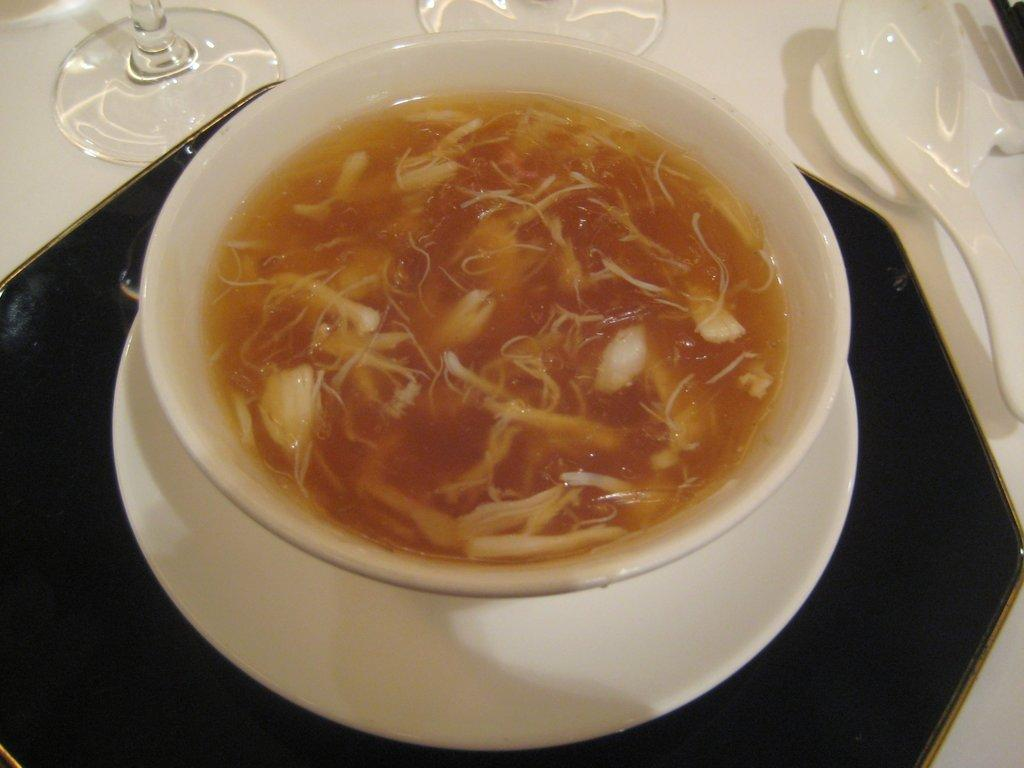What is in the cup that is visible in the image? There is a cup of soap in the image. What other items can be seen in the image? There are glasses and spoons visible in the image. Where are these items located in the image? All items are placed on a table. What is the name of the town where the houses in the image are located? There are no houses or towns present in the image; it only features a cup of soap, glasses, and spoons on a table. 